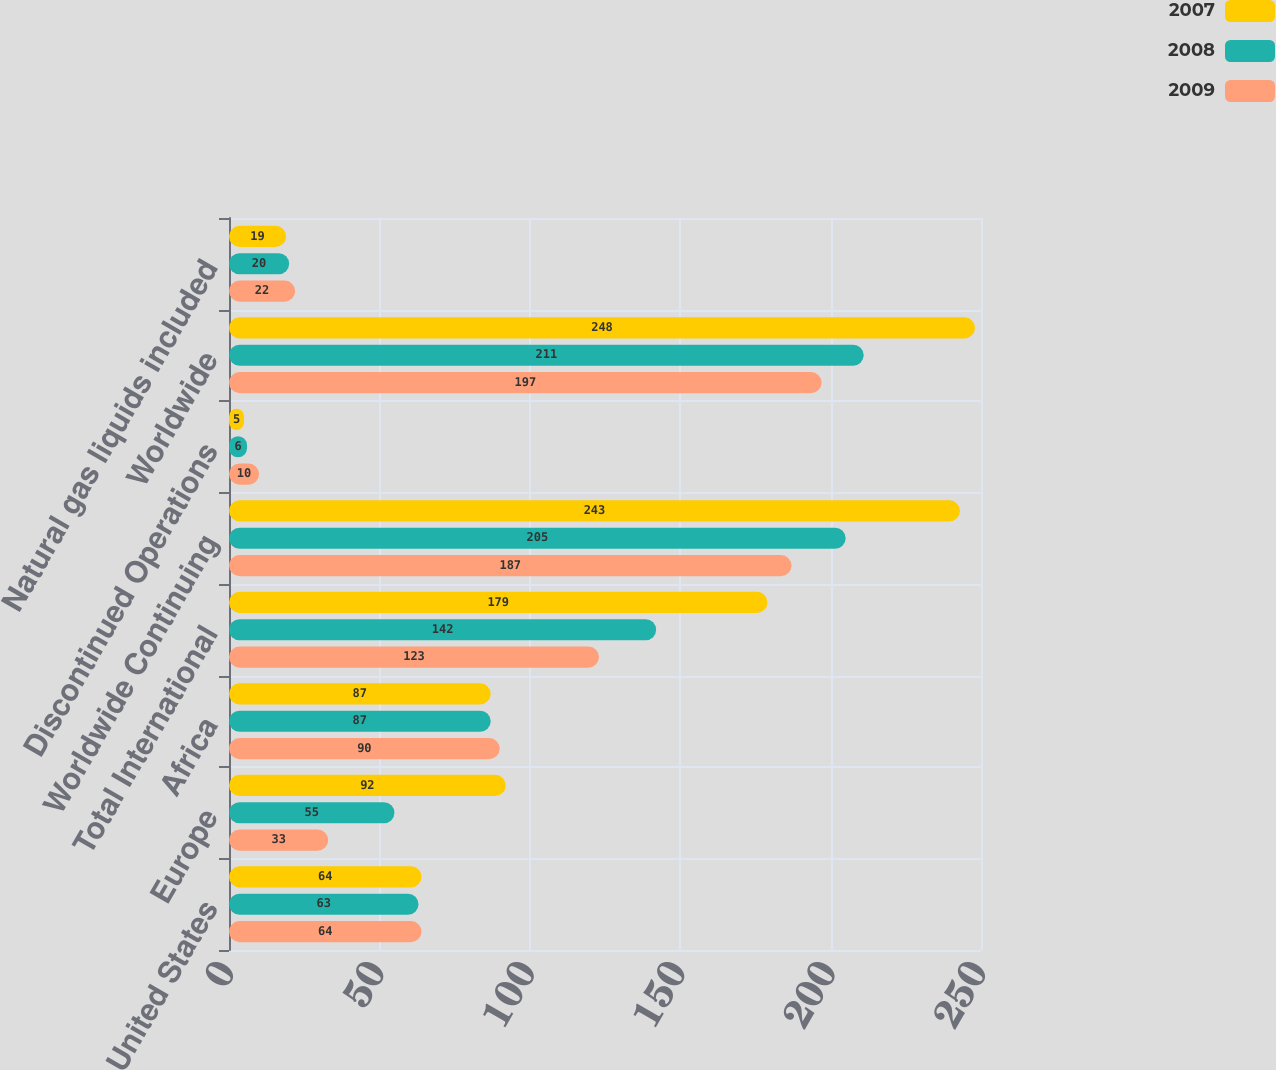Convert chart. <chart><loc_0><loc_0><loc_500><loc_500><stacked_bar_chart><ecel><fcel>United States<fcel>Europe<fcel>Africa<fcel>Total International<fcel>Worldwide Continuing<fcel>Discontinued Operations<fcel>Worldwide<fcel>Natural gas liquids included<nl><fcel>2007<fcel>64<fcel>92<fcel>87<fcel>179<fcel>243<fcel>5<fcel>248<fcel>19<nl><fcel>2008<fcel>63<fcel>55<fcel>87<fcel>142<fcel>205<fcel>6<fcel>211<fcel>20<nl><fcel>2009<fcel>64<fcel>33<fcel>90<fcel>123<fcel>187<fcel>10<fcel>197<fcel>22<nl></chart> 